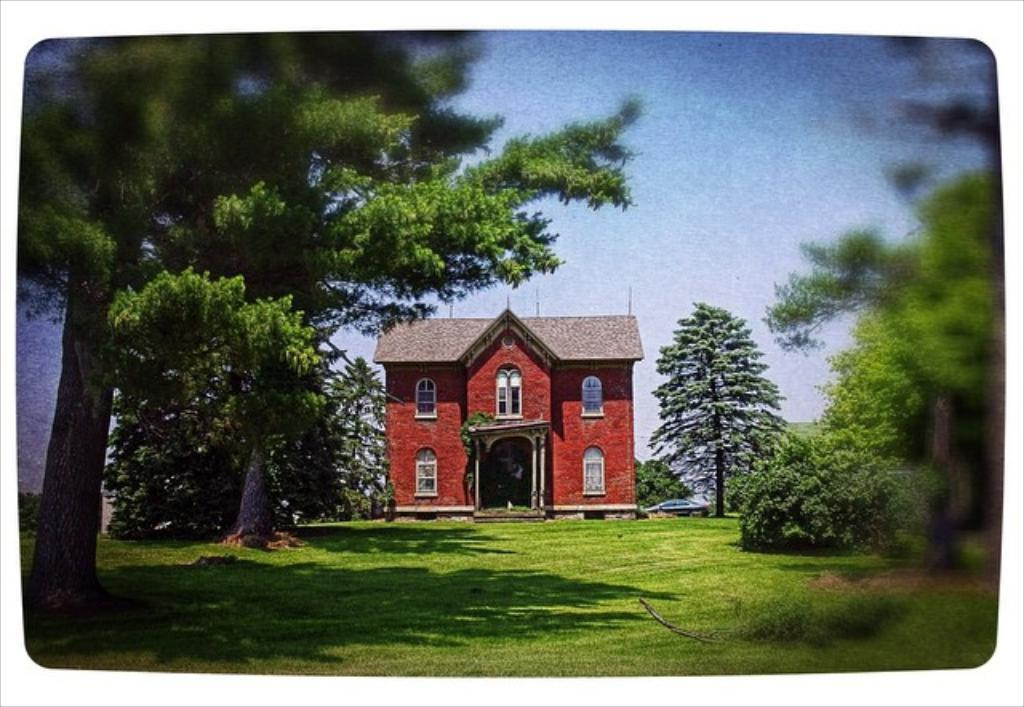What type of vegetation can be seen in the image? There is grass in the image. What mode of transportation is present in the image? There is a car in the image. What other natural elements can be seen in the image? There are trees in the image. What type of structure is visible in the image? There is a building with windows in the image. What is visible in the background of the image? The sky is visible in the background of the image. What type of hammer is being used to pick berries in the image? There is no hammer or berries present in the image. What form does the building take in the image? The building in the image has a rectangular shape with windows. 